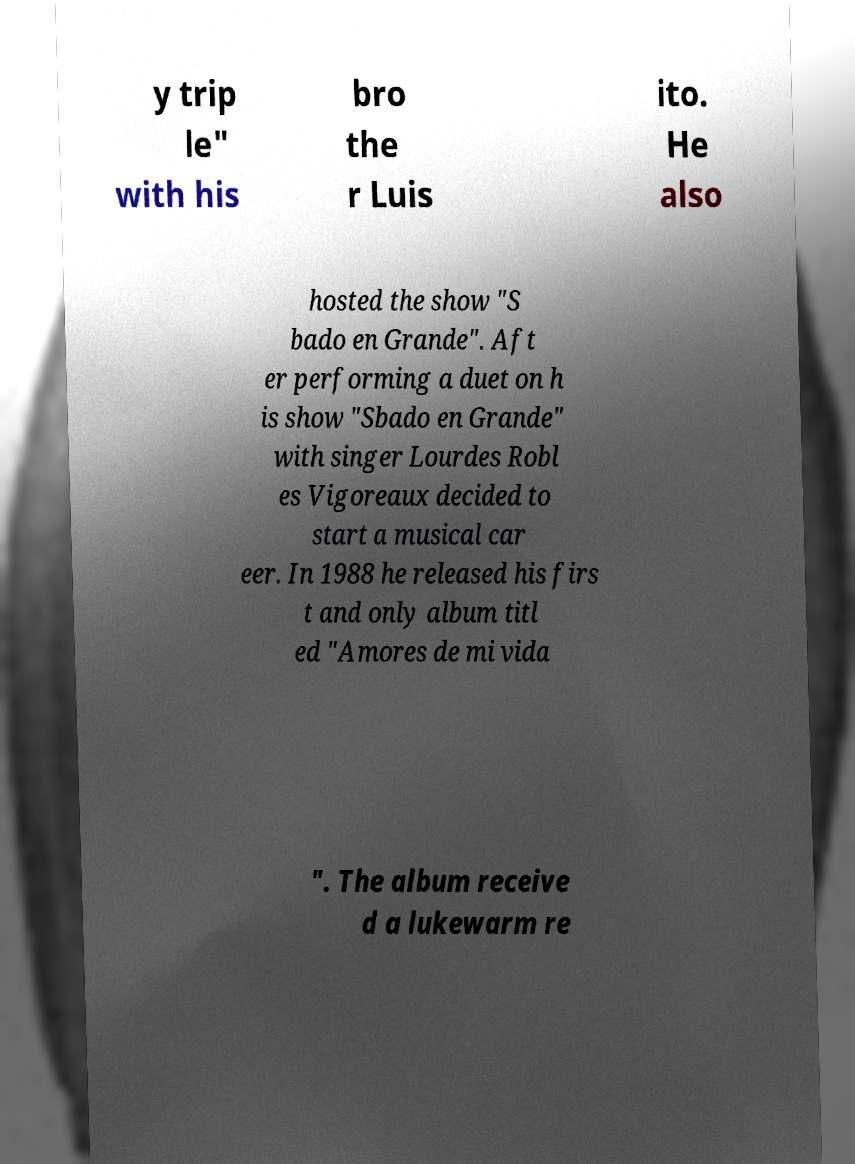Please identify and transcribe the text found in this image. y trip le" with his bro the r Luis ito. He also hosted the show "S bado en Grande". Aft er performing a duet on h is show "Sbado en Grande" with singer Lourdes Robl es Vigoreaux decided to start a musical car eer. In 1988 he released his firs t and only album titl ed "Amores de mi vida ". The album receive d a lukewarm re 